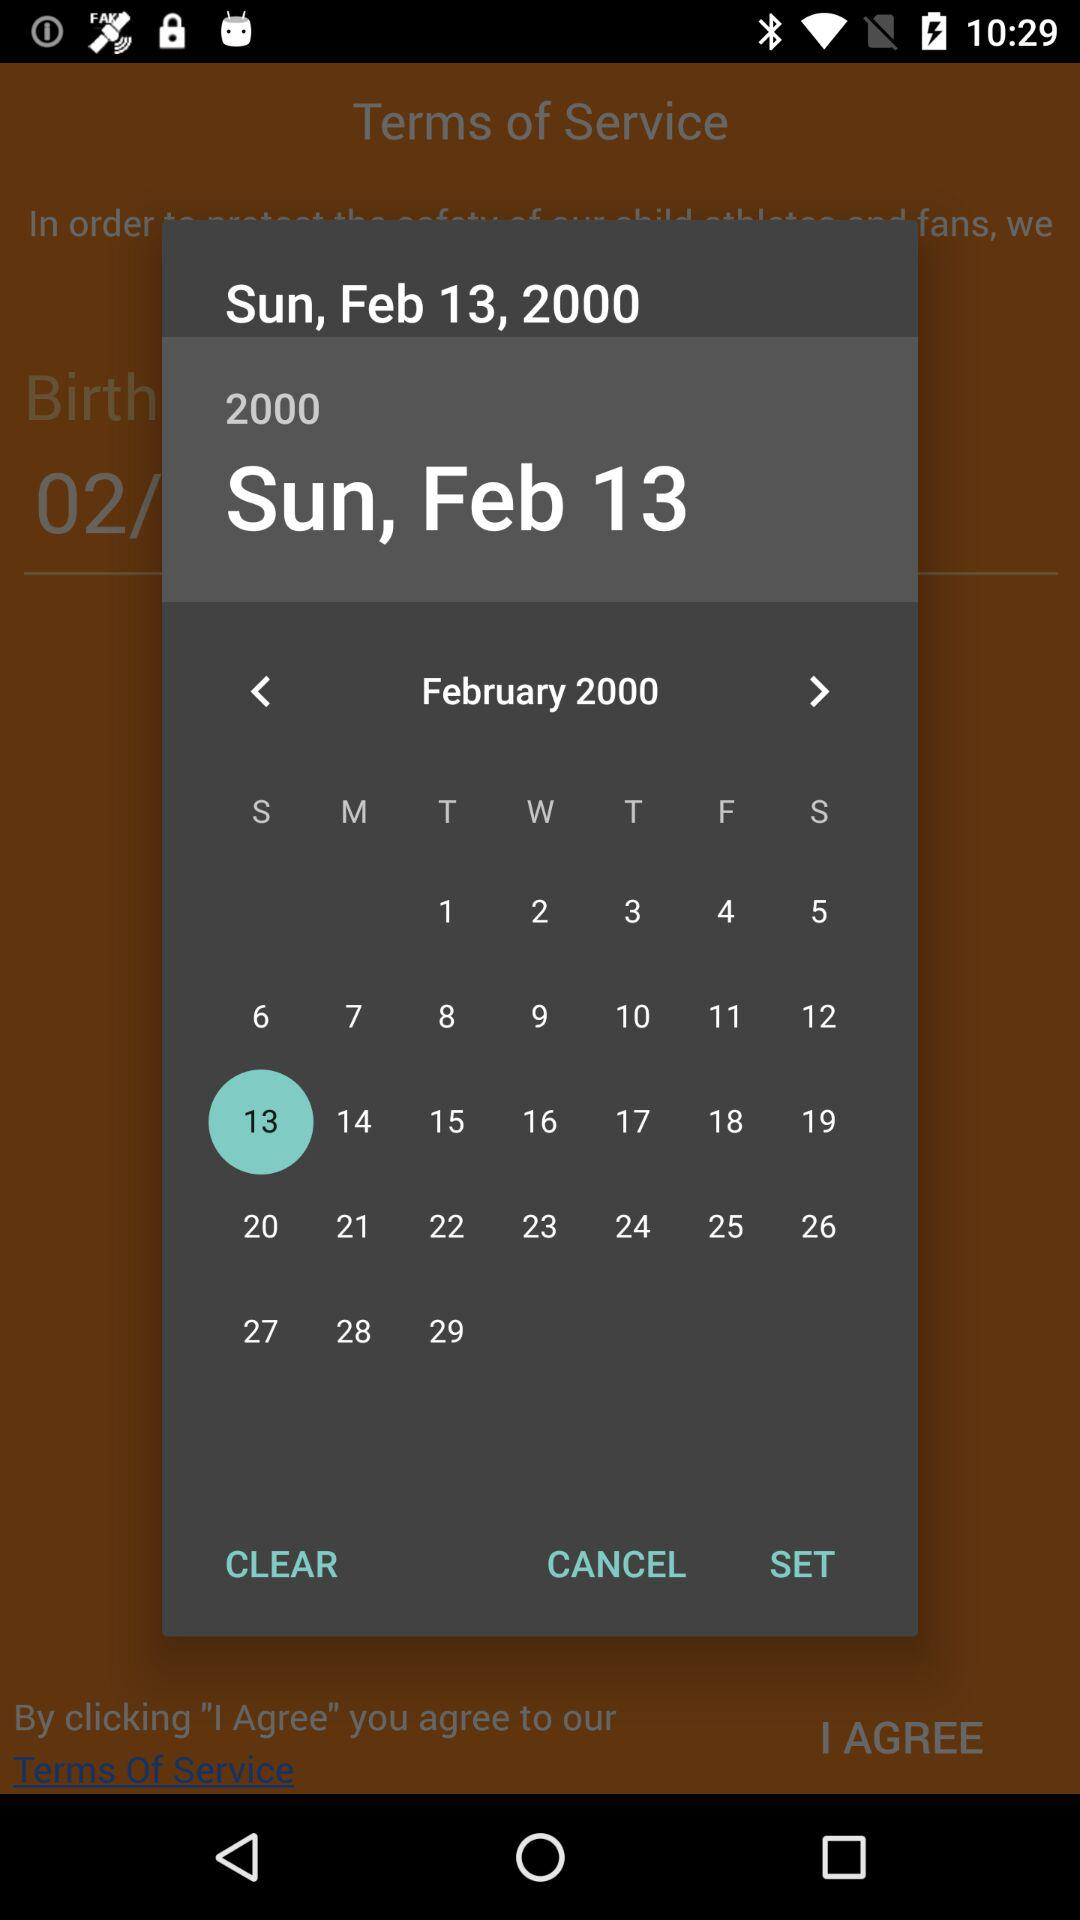What date is selected in the calendar? The selected date is Sunday, February 13, 2000. 